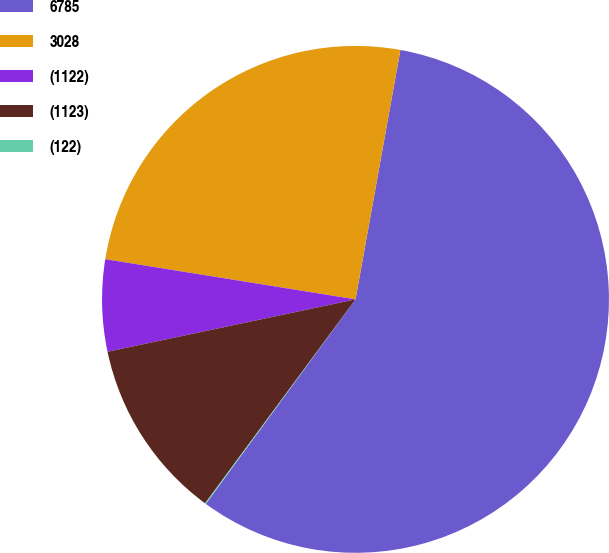<chart> <loc_0><loc_0><loc_500><loc_500><pie_chart><fcel>6785<fcel>3028<fcel>(1122)<fcel>(1123)<fcel>(122)<nl><fcel>57.22%<fcel>25.3%<fcel>5.85%<fcel>11.57%<fcel>0.06%<nl></chart> 